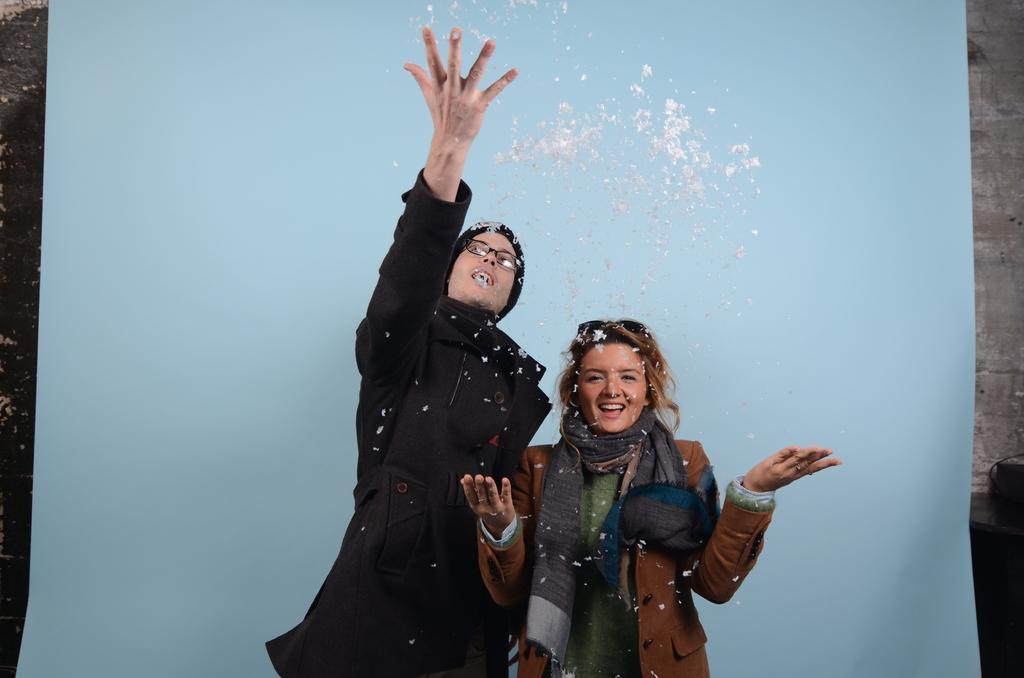Can you describe this image briefly? In this image we can see two persons standing, behind them, we can see an object, which looks like a banner and in the background, we can see the wall. 